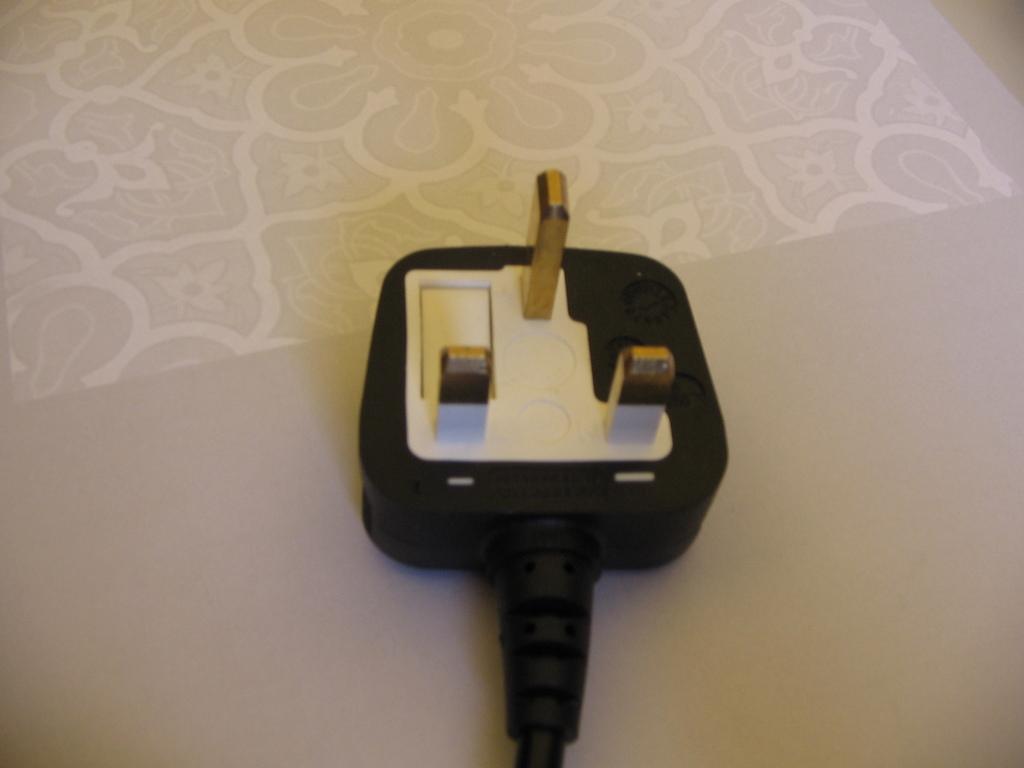Please provide a concise description of this image. In the picture we can see a cream color surface with some designs on it and on it we can see a switch which is black in color with three pins to it. 